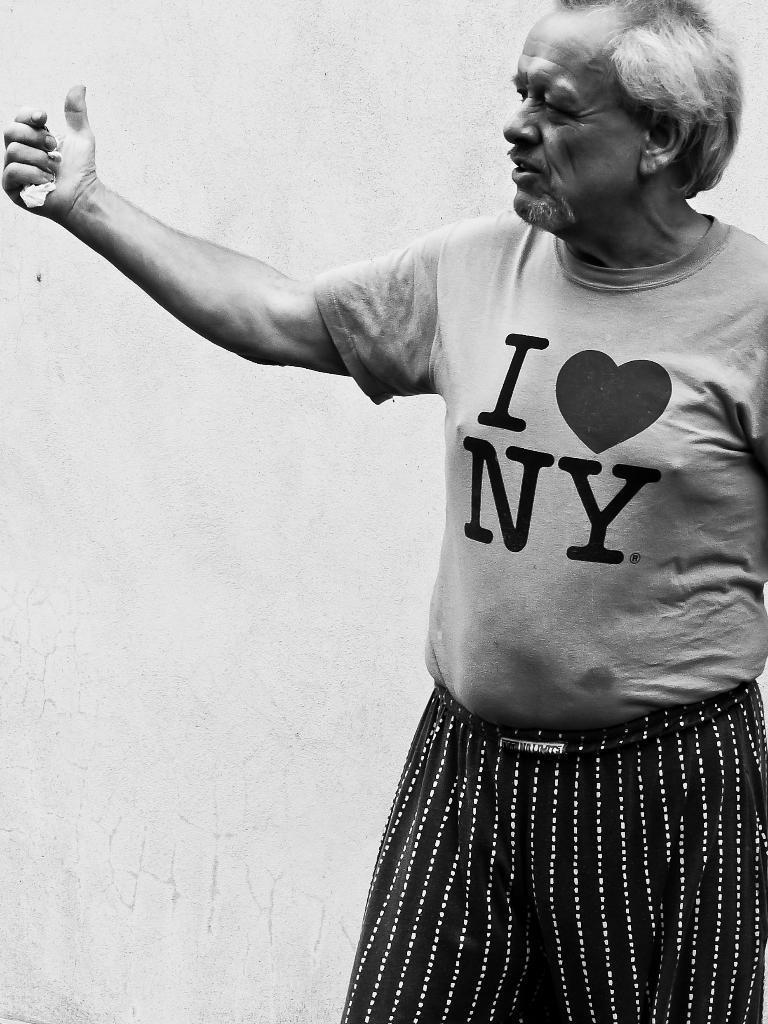How would you summarize this image in a sentence or two? In this image I can see a man is standing. The man is wearing a T-shirt. This picture is black and white in color. 